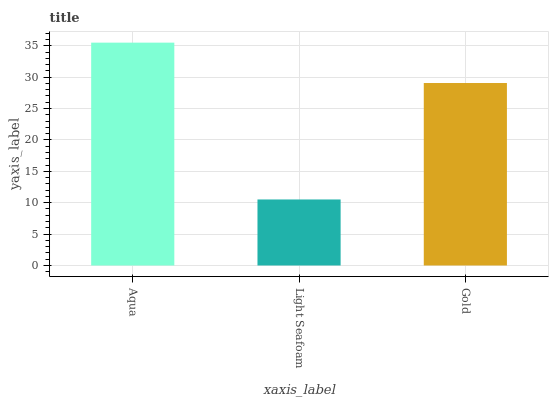Is Light Seafoam the minimum?
Answer yes or no. Yes. Is Aqua the maximum?
Answer yes or no. Yes. Is Gold the minimum?
Answer yes or no. No. Is Gold the maximum?
Answer yes or no. No. Is Gold greater than Light Seafoam?
Answer yes or no. Yes. Is Light Seafoam less than Gold?
Answer yes or no. Yes. Is Light Seafoam greater than Gold?
Answer yes or no. No. Is Gold less than Light Seafoam?
Answer yes or no. No. Is Gold the high median?
Answer yes or no. Yes. Is Gold the low median?
Answer yes or no. Yes. Is Light Seafoam the high median?
Answer yes or no. No. Is Aqua the low median?
Answer yes or no. No. 